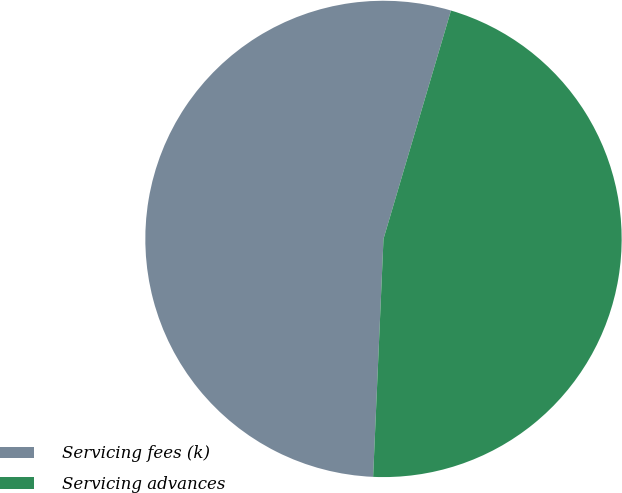<chart> <loc_0><loc_0><loc_500><loc_500><pie_chart><fcel>Servicing fees (k)<fcel>Servicing advances<nl><fcel>53.88%<fcel>46.12%<nl></chart> 